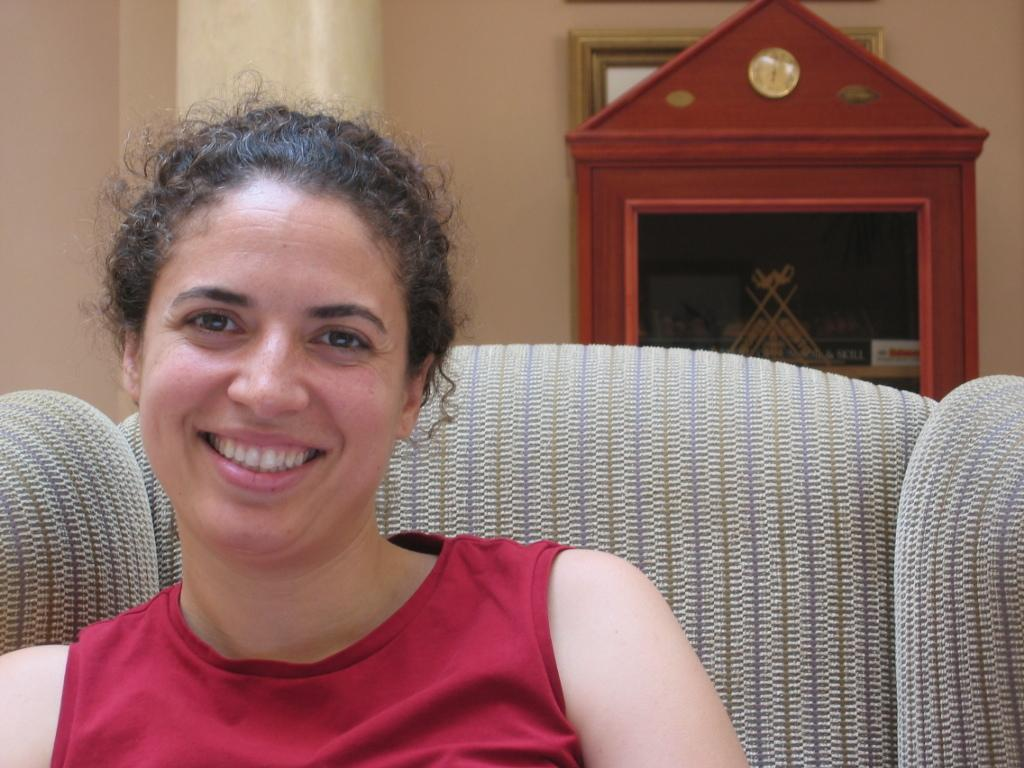What is the lady doing in the image? The lady is sitting on the sofa in the image. Where is the sofa located in the image? The sofa is in the foreground area of the image. How is the image presented? The image appears to be framed. What can be seen in the background of the image? There is a wooden rack and a pillar in the background of the image. What type of arithmetic problem is the lady solving on the sofa? There is no indication in the image that the lady is solving an arithmetic problem; she is simply sitting on the sofa. 